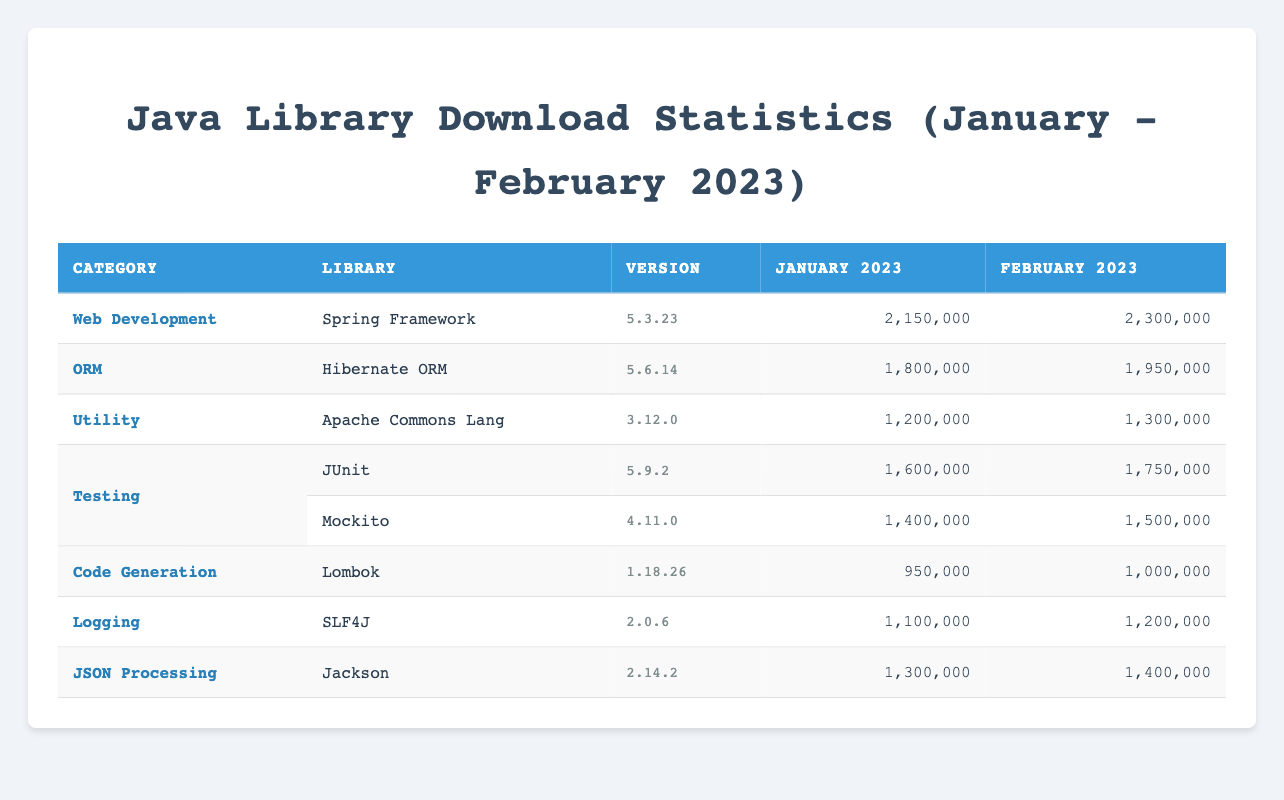What were the total downloads for the Spring Framework in January 2023? The download count for the Spring Framework in January 2023 can be found in the Downloads column for that library. According to the table, it shows 2,150,000 downloads.
Answer: 2,150,000 Did Hibernate ORM have more downloads in February 2023 than in January 2023? By comparing the downloads for Hibernate ORM in January (1,800,000) and February (1,950,000), we see that the February number is higher than the January number. Therefore, it had more downloads in February 2023.
Answer: Yes What is the average number of downloads for JUnit and Mockito in February 2023? The downloads for JUnit in February 2023 are 1,750,000, and for Mockito, it is 1,500,000. To calculate the average, we sum these values (1,750,000 + 1,500,000 = 3,250,000) and divide by 2, which gives us an average of 1,625,000.
Answer: 1,625,000 Which library in the Testing category had more downloads in January 2023? The downloads for JUnit are 1,600,000, and for Mockito, it is 1,400,000 in January 2023. Comparing these, JUnit had more downloads as 1,600,000 is greater than 1,400,000.
Answer: JUnit What is the total number of downloads for all libraries in January 2023? We need to sum the downloads of all libraries for January 2023: Spring Framework (2,150,000) + Hibernate ORM (1,800,000) + Apache Commons Lang (1,200,000) + JUnit (1,600,000) + Mockito (1,400,000) + Lombok (950,000) + SLF4J (1,100,000) + Jackson (1,300,000) = 11,450,000.
Answer: 11,450,000 Was there a library in the Utility category that had more downloads in January than any library in the ORM category? The Utility category includes Apache Commons Lang with 1,200,000 downloads in January, while the ORM category includes Hibernate ORM with 1,800,000 downloads. Since 1,200,000 is less than 1,800,000, there was no Utility library with more downloads than ORM.
Answer: No Which month's downloads were higher for SLF4J, January or February 2023? By comparing the downloads, we find SLF4J had 1,100,000 downloads in January and 1,200,000 in February. Since 1,200,000 is greater than 1,100,000, February's downloads were higher.
Answer: February 2023 Is Apache Commons Lang the only library listed in the Utility category for the months specified? The table clearly states that Apache Commons Lang is categorized under Utility, and there are no other entries in that category. Thus, it is the only library under Utility in the listed data.
Answer: Yes 